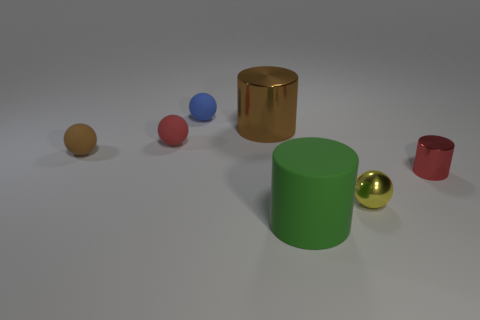Are the red cylinder and the large object that is behind the large green rubber cylinder made of the same material?
Offer a very short reply. Yes. Are there fewer big green things that are left of the small metal ball than rubber objects to the right of the small brown rubber object?
Ensure brevity in your answer.  Yes. The big thing that is made of the same material as the tiny brown thing is what color?
Provide a succinct answer. Green. Are there any small balls in front of the small red object to the right of the yellow object?
Ensure brevity in your answer.  Yes. The metallic cylinder that is the same size as the green matte cylinder is what color?
Your answer should be compact. Brown. How many things are either tiny cylinders or large red rubber cubes?
Your answer should be very brief. 1. There is a cylinder that is on the left side of the big object that is in front of the red shiny cylinder that is in front of the brown cylinder; what size is it?
Make the answer very short. Large. What number of tiny rubber spheres have the same color as the small shiny cylinder?
Your answer should be very brief. 1. How many tiny red things have the same material as the blue ball?
Give a very brief answer. 1. How many things are either green cylinders or large things that are in front of the yellow metallic object?
Offer a very short reply. 1. 